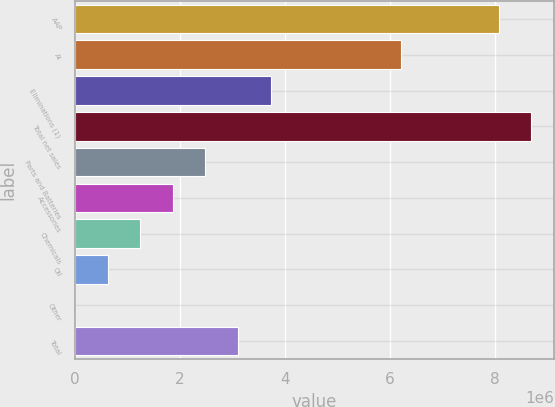Convert chart to OTSL. <chart><loc_0><loc_0><loc_500><loc_500><bar_chart><fcel>AAP<fcel>AI<fcel>Eliminations (1)<fcel>Total net sales<fcel>Parts and Batteries<fcel>Accessories<fcel>Chemicals<fcel>Oil<fcel>Other<fcel>Total<nl><fcel>8.0665e+06<fcel>6.205e+06<fcel>3.723e+06<fcel>8.687e+06<fcel>2.482e+06<fcel>1.8615e+06<fcel>1.241e+06<fcel>620501<fcel>1<fcel>3.1025e+06<nl></chart> 